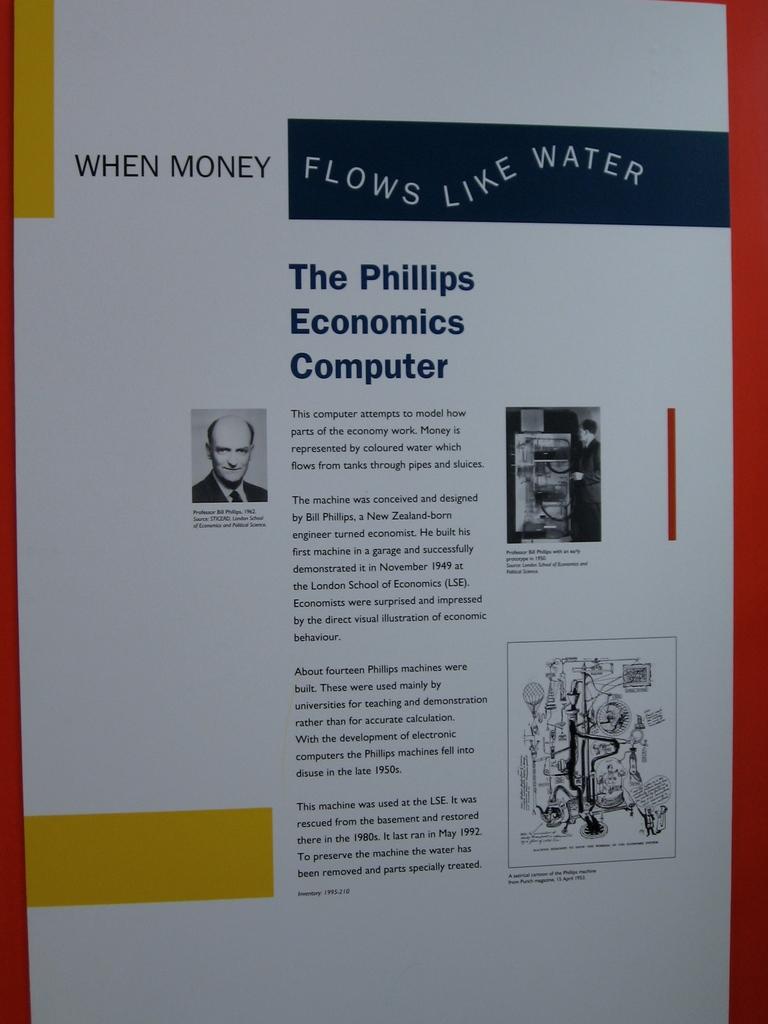What flows like water?
Your response must be concise. Money. What is written in the black block?
Keep it short and to the point. Flows like water. 